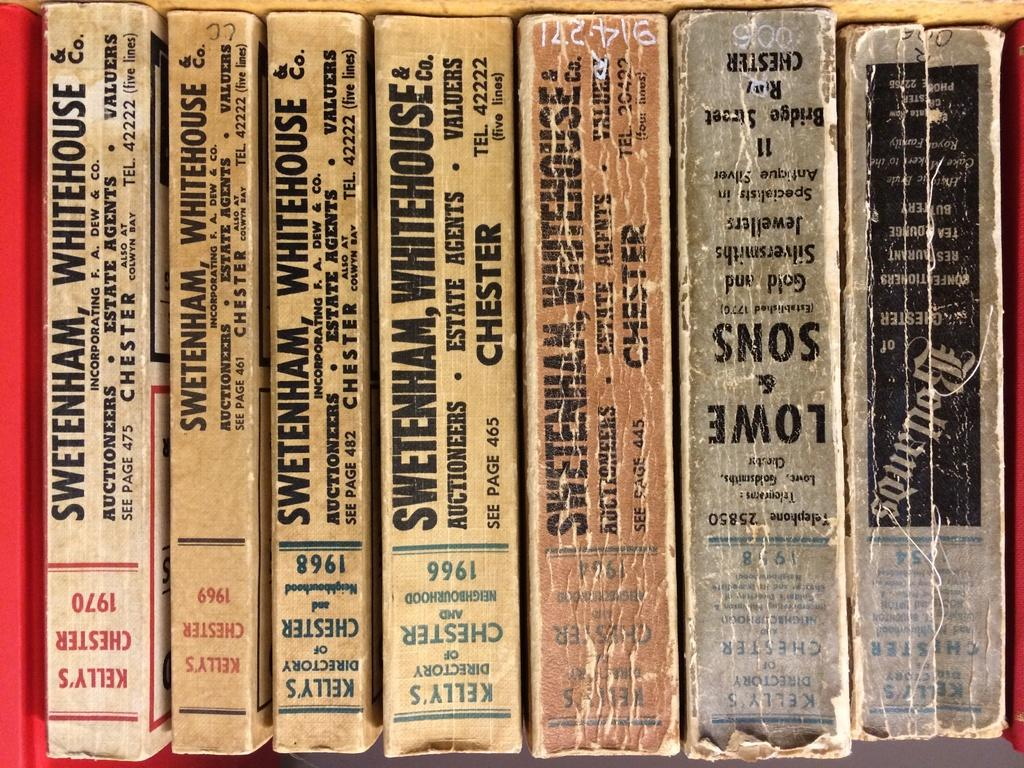Provide a one-sentence caption for the provided image. The binders of a few old books date to the 1960's and 1970's. 